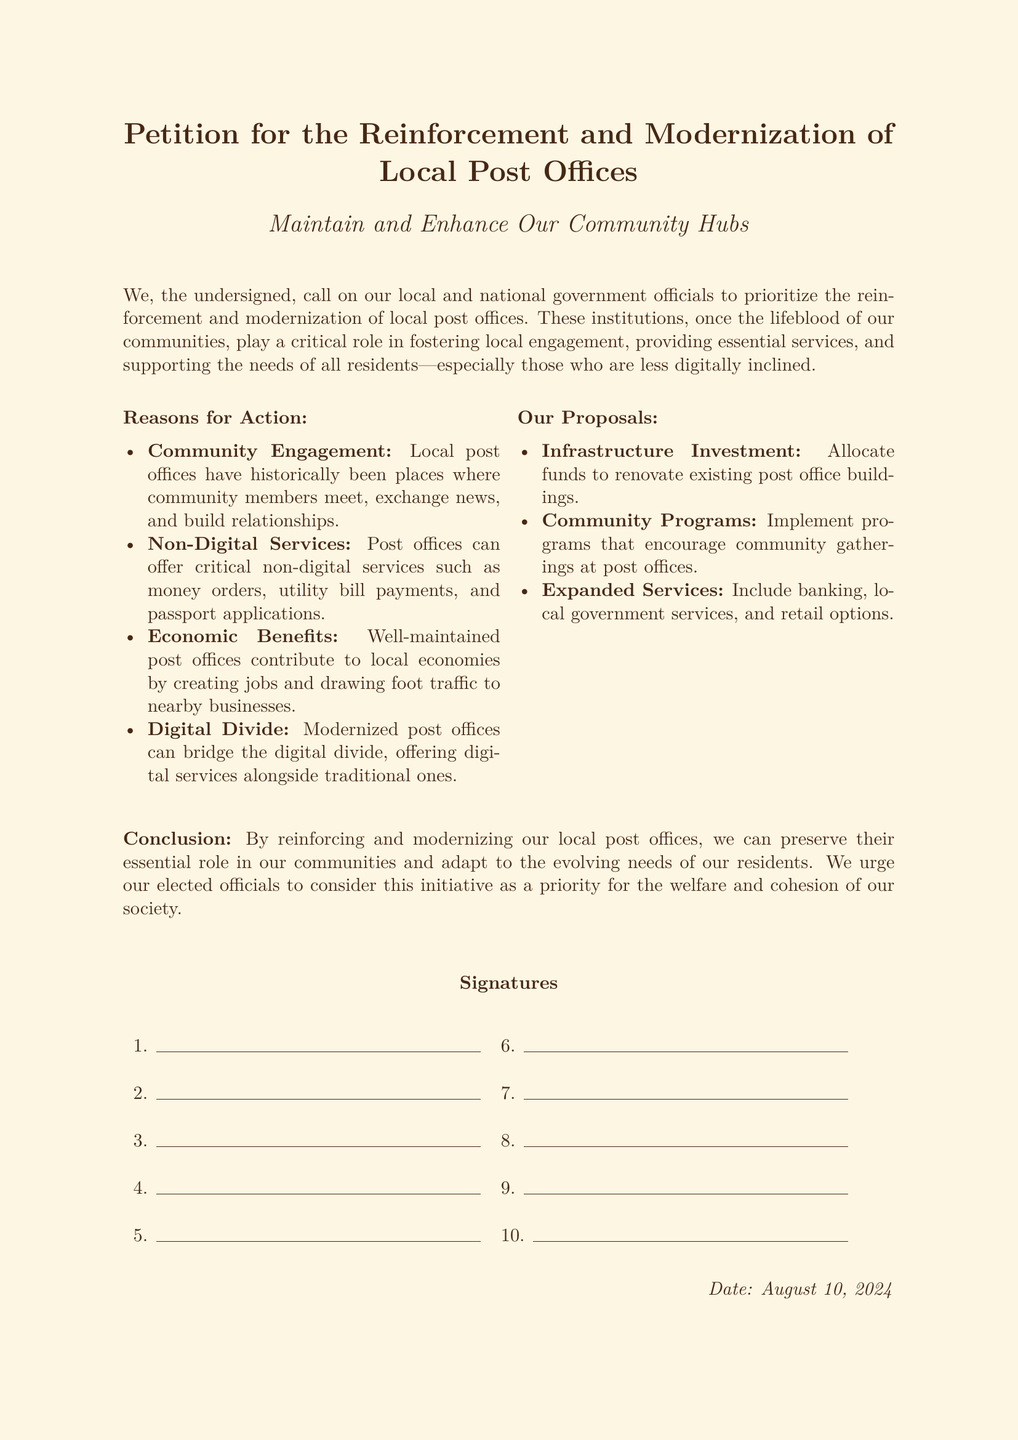What is the title of the petition? The title is specified at the top of the document, describing the main focus of the petition.
Answer: Petition for the Reinforcement and Modernization of Local Post Offices Who is this petition addressed to? The petition indicates that it is directed towards local and national government officials.
Answer: Local and national government officials What are the reasons for action listed in the document? The document provides a list of reasons under the "Reasons for Action" section, summarizing the key points.
Answer: Community Engagement, Non-Digital Services, Economic Benefits, Digital Divide What is one of the proposals mentioned in the document? The document outlines a set of proposals intended to reinforce local post offices, which can be found under the "Our Proposals" section.
Answer: Infrastructure Investment How many signature lines are provided in the document? The signature section in the document contains ten lines for signatures.
Answer: 10 What date is included at the bottom of the document? The date at the bottom reflects when the petition was completed and is noted with a specific command.
Answer: TODAY What type of services does the petition advocate for local post offices to offer? The petition discusses the importance of non-digital services that post offices can provide, specifically mentioning several examples.
Answer: Money orders, utility bill payments, passport applications What is the main conclusion of the petition? The document concludes with a summary of the overall message and urgency for action regarding the petition’s objectives.
Answer: Preserve their essential role in our communities What is the color of the page background in this document? The document indicates a specific color for the page background, mentioned within the styling properties.
Answer: Oldpaper 